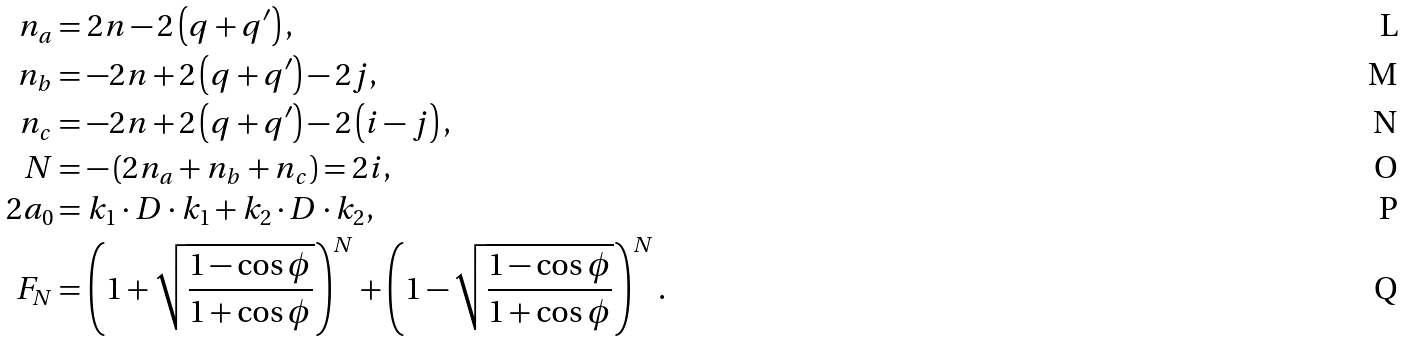<formula> <loc_0><loc_0><loc_500><loc_500>n _ { a } & = 2 n - 2 \left ( q + q ^ { \prime } \right ) , \\ n _ { b } & = - 2 n + 2 \left ( q + q ^ { \prime } \right ) - 2 j , \\ n _ { c } & = - 2 n + 2 \left ( q + q ^ { \prime } \right ) - 2 \left ( i - j \right ) , \\ N & = - \left ( 2 n _ { a } + n _ { b } + n _ { c } \right ) = 2 i , \\ 2 a _ { 0 } & = k _ { 1 } \cdot D \cdot k _ { 1 } + k _ { 2 } \cdot D \cdot k _ { 2 } , \\ F _ { N } & = \left ( 1 + \sqrt { \frac { 1 - \cos \phi } { 1 + \cos \phi } } \right ) ^ { N } + \left ( 1 - \sqrt { \frac { 1 - \cos \phi } { 1 + \cos \phi } } \right ) ^ { N } .</formula> 